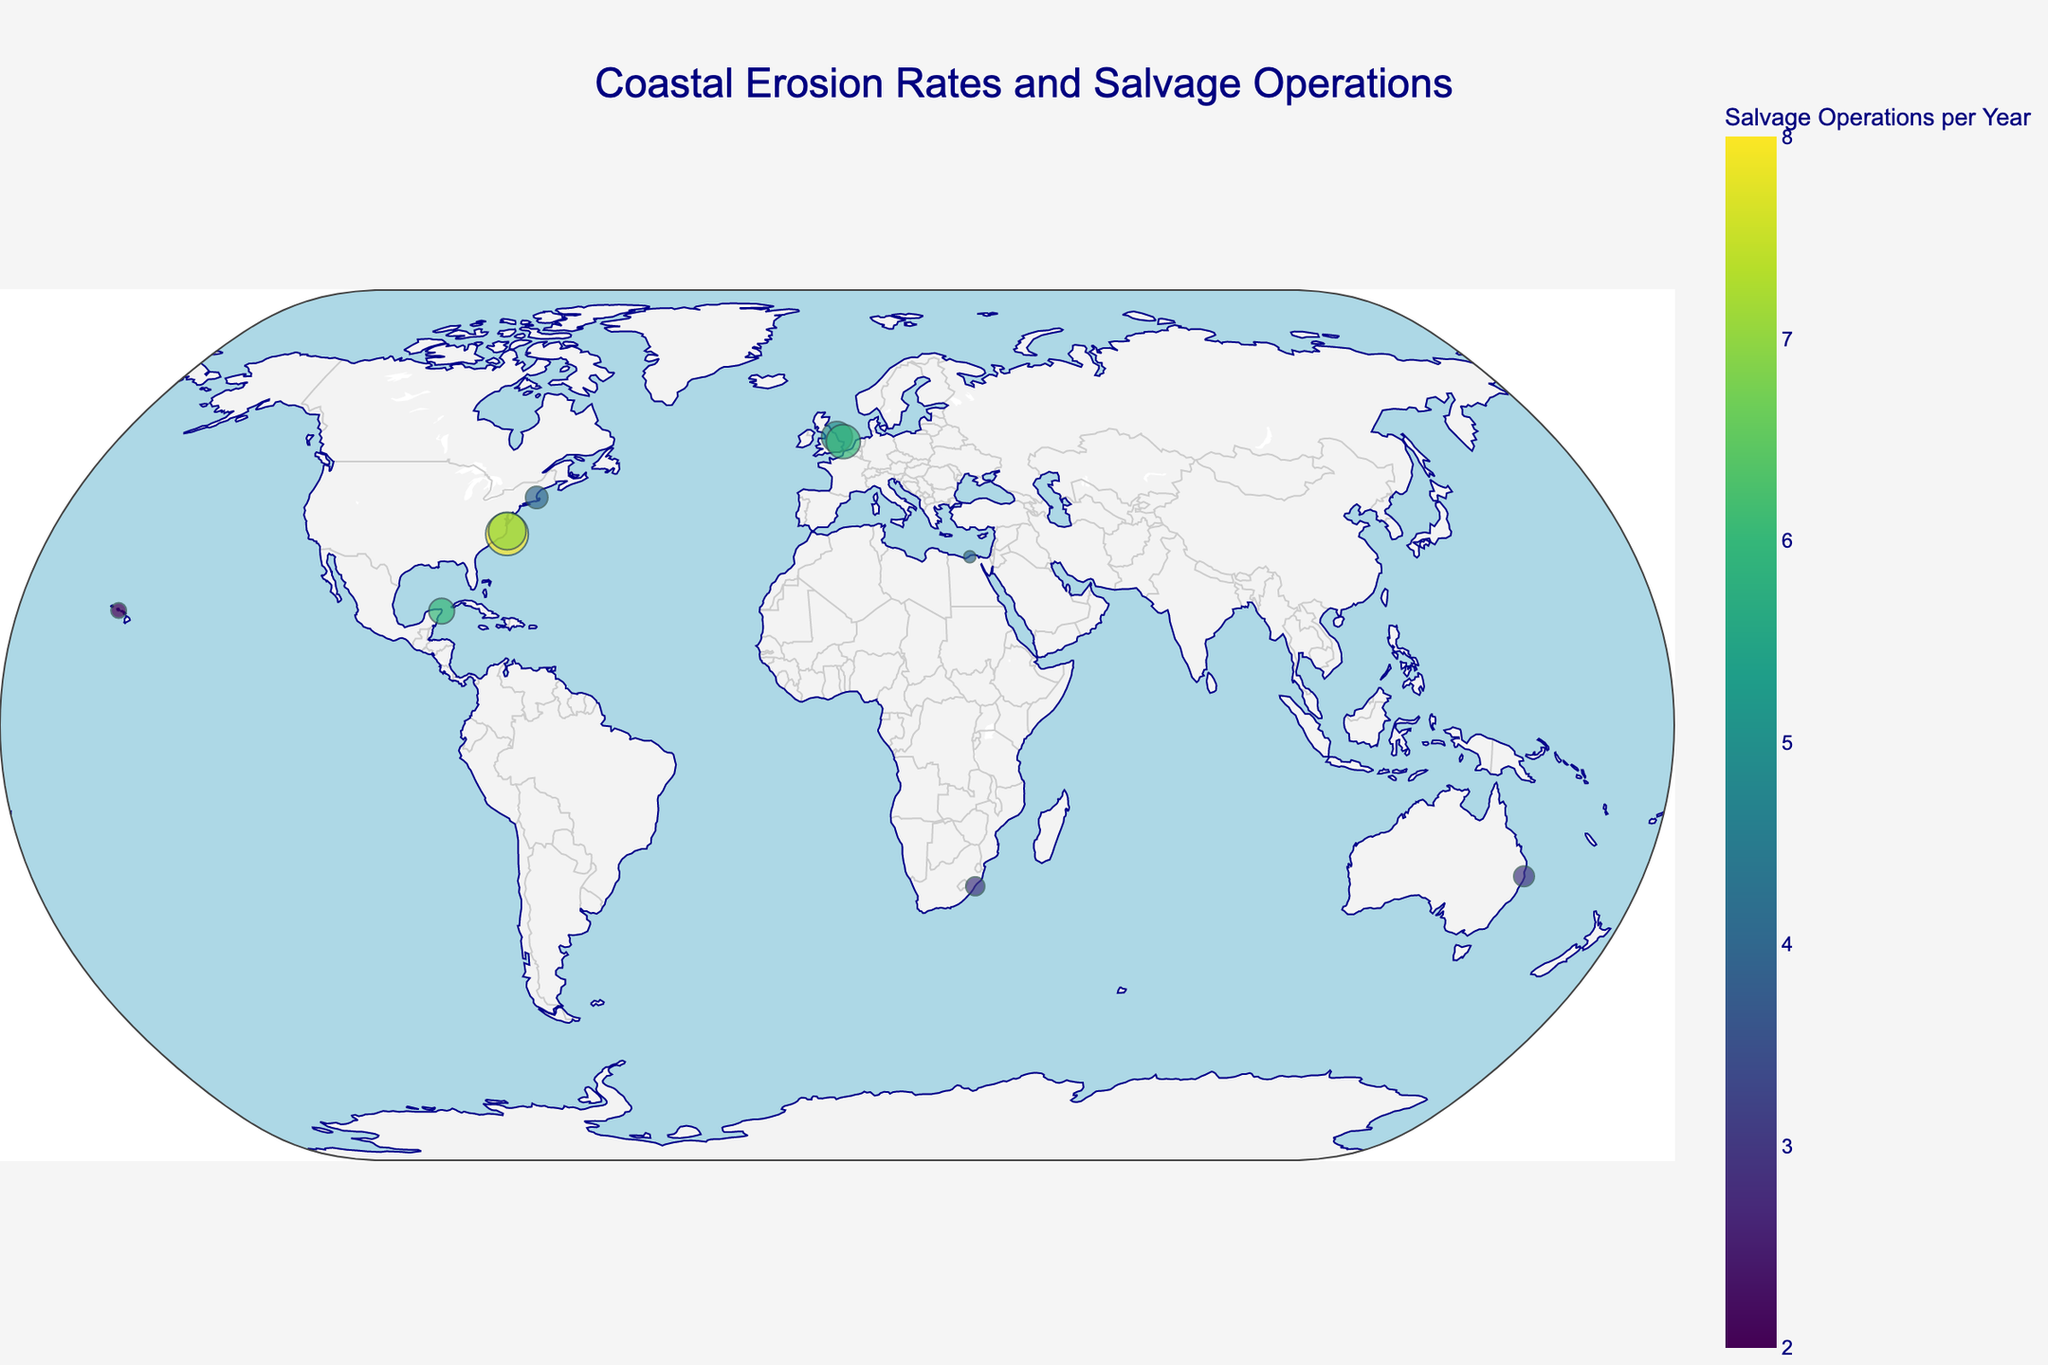What is the title of the plot? The title is typically displayed at the top of the plot and provides a summary of the information being shown. In this figure, the title is given as "Coastal Erosion Rates and Salvage Operations".
Answer: Coastal Erosion Rates and Salvage Operations How many regions are represented in the plot? Count the number of distinct regions listed in the hover text or in the data points. Each marker represents a region, and there are 10 unique regions displayed.
Answer: 10 Which region shows the highest erosion rate? Look for the marker with the largest size since the size of the marker represents the erosion rate. The Outer Banks NC has the largest marker size indicating an erosion rate of 2.5 cm/year.
Answer: Outer Banks NC What is the color scale representing in this plot? The color scale shown by the color bar on the plot represents the number of salvage operations per year. The description of the color bar confirms this interpretation.
Answer: Salvage Operations per Year Identify a region with a relatively low rate of erosion and low number of salvage operations. Locate a marker that is small in size and uses a cooler color from the color scale. Alexandria, Egypt, has an erosion rate of 0.7 cm/year and 4 salvage operations per year, meeting the criteria.
Answer: Alexandria, Egypt What is the average erosion rate among the UK regions depicted? Identify the UK regions (Holderness Coast and Happisburgh) and calculate their average erosion rate. Holderness Coast: 1.8 cm/year, and Happisburgh: 2.0 cm/year. The average is (1.8 + 2.0) / 2 = 1.9 cm/year.
Answer: 1.9 cm/year Compare the erosion rates between Nags Head NC and Scituate MA. Which one is higher? Identify the markers for Nags Head NC and Scituate MA. Nags Head NC has an erosion rate of 2.2 cm/year and Scituate MA has an erosion rate of 1.3 cm/year. Therefore, Nags Head NC has the higher erosion rate.
Answer: Nags Head NC Which region has the highest number of salvage operations per year but a moderate erosion rate? Find the marker with the highest color intensity (representing the highest number of salvage operations) and check its size. Outer Banks NC has the highest number of salvage operations (8 per year) and a moderate erosion rate (2.5 cm/year).
Answer: Outer Banks NC How does the erosion rate in Cancun, Mexico compare to the global average depicted? Calculate the global average erosion rate and compare it to Cancun's erosion rate. The global average is the sum of all erosion rates divided by the number of regions (sum = 15.2, regions = 10, average = 1.52 cm/year). Cancun's erosion rate is 1.5 cm/year, which is slightly lower than the average.
Answer: Slightly lower than average What geographic projection is used in this plot? Check the settings mentioned in the plot description. The projection type is specified as "natural earth," commonly used for plotting global data.
Answer: Natural Earth 